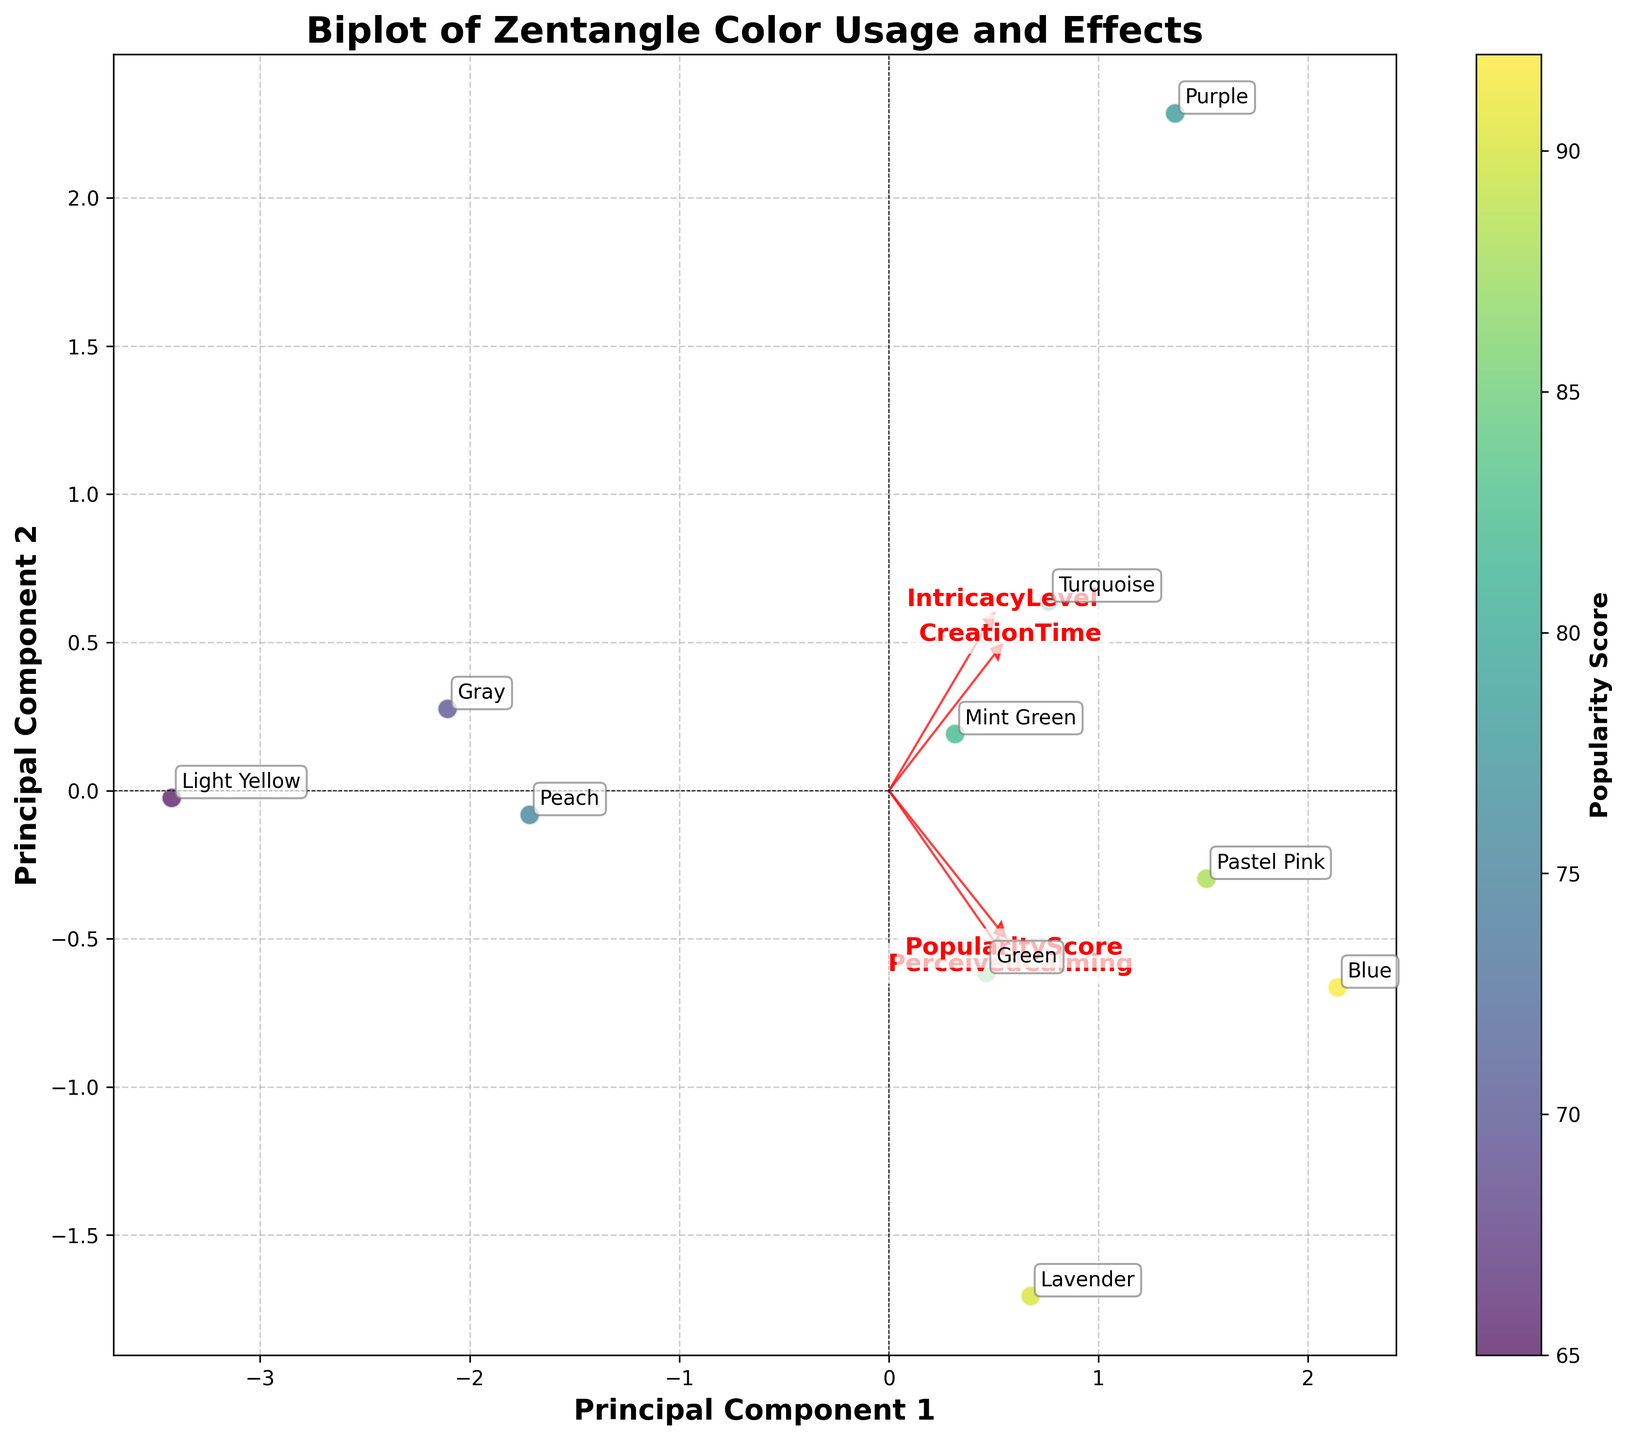how many colors were analyzed in the Biplot? The Biplot shows each color used in the Zentangle pieces. Counting the unique color labels annotated on the plot will give the number of colors analyzed.
Answer: 10 What are the axes labels in the Biplot? Observing the labels on the horizontal and vertical axes of the Biplot provides this information. The labels indicate the principal components derived from PCA.
Answer: Principal Component 1 and Principal Component 2 Which color appears to have the highest Perceived Calming effect according to the Biplot? Identify the color label nearest to the vector representing "PerceivedCalming" which points in the positive direction.
Answer: Blue Based on the Biplot, which feature is most strongly correlated with Principal Component 1? The length and direction of the vectors give information about their correlation with the principal components. The vector pointing most prominently along Principal Component 1 shows the strongest correlation.
Answer: PopularityScore How does the Popularity Score correlate with the Creation Time according to the Biplot? Check the orientation of the vectors for "PopularityScore" and "CreationTime". If they are pointing in similar directions, it indicates a positive correlation; if opposite, a negative correlation; if perpendicular, no correlation.
Answer: Positive correlation Which two colors are most similar in terms of their relationships to the principal components? Examine the positions of the color labels on the Biplot. The two labels that are closest to each other in the plot would be considered most similar in terms of their principal component relationships.
Answer: Green and Pastel Pink Which feature has the weakest correlation with Principal Component 2? Look at the vectors representing features in the Biplot. The vector that is closest to horizontal, indicating minimal vertical displacement, corresponds to the weakest correlation with Principal Component 2.
Answer: IntricacyLevel Among the colors analyzed, which one is least associated with high Perceived Calming yet moderately popular according to the Biplot? Locate the color label that is far from the "PerceivedCalming" vector but is somewhat aligned with or near the "PopularityScore" vector.
Answer: Gray Is there any color that shows a strong alignment with more than one feature vector? Identify any color label that is closely positioned along the direction where multiple feature vectors converge, indicating strong alignment with those features.
Answer: Blue Which direction does the "IntricacyLevel" vector point to, and what does it indicate about its relationship with the principal components? Look at the direction in which the "IntricacyLevel" vector points. This will indicate how it relates to Principal Component 1 and Principal Component 2 based on the Biplot orientation.
Answer: Bottom-right, indicating a moderate positive relationship with both components 